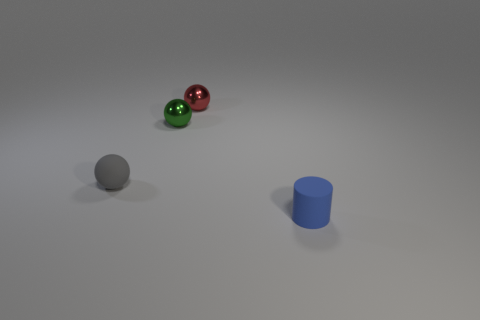There is a ball that is left of the tiny metal thing that is on the left side of the red shiny ball; how big is it?
Your answer should be very brief. Small. Are there more small purple things than tiny matte cylinders?
Give a very brief answer. No. Are there more blue cylinders to the left of the tiny red ball than small red metal spheres on the left side of the gray ball?
Provide a short and direct response. No. There is a object that is both in front of the tiny green ball and behind the blue rubber object; what is its size?
Offer a terse response. Small. How many other matte spheres are the same size as the gray sphere?
Offer a very short reply. 0. There is a metal object that is in front of the small red shiny object; is its shape the same as the blue thing?
Give a very brief answer. No. Are there fewer red metal spheres right of the small red shiny thing than tiny red shiny spheres?
Keep it short and to the point. Yes. Is there a metal thing that has the same color as the matte sphere?
Provide a short and direct response. No. Is the shape of the small blue rubber thing the same as the object behind the green sphere?
Give a very brief answer. No. Are there any red balls made of the same material as the small cylinder?
Ensure brevity in your answer.  No. 